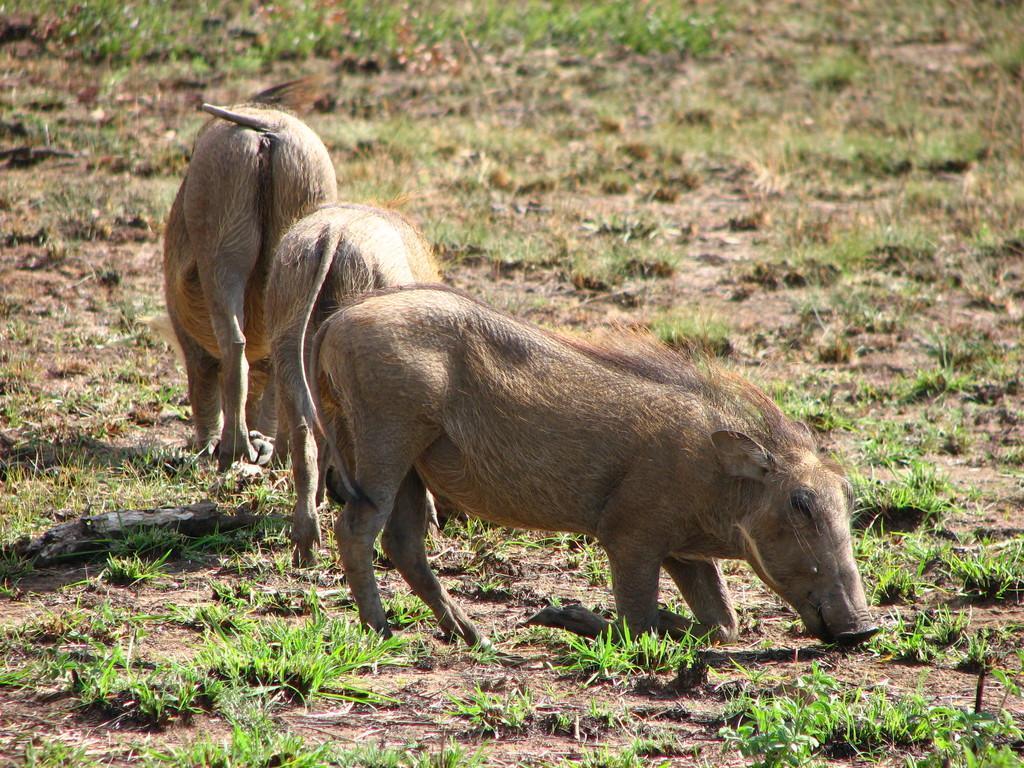Please provide a concise description of this image. This image I can see three pigs on the ground. On the left side there is a stick. On the ground, I can see the grass. 